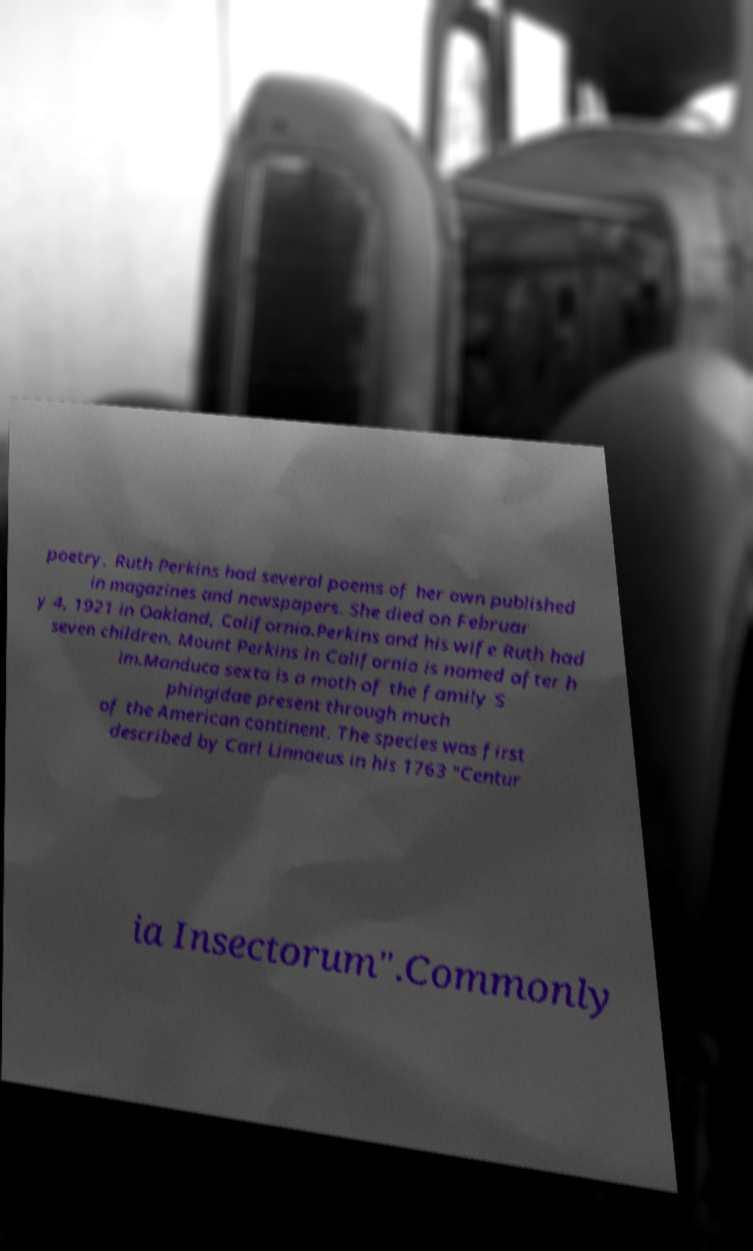For documentation purposes, I need the text within this image transcribed. Could you provide that? poetry, Ruth Perkins had several poems of her own published in magazines and newspapers. She died on Februar y 4, 1921 in Oakland, California.Perkins and his wife Ruth had seven children. Mount Perkins in California is named after h im.Manduca sexta is a moth of the family S phingidae present through much of the American continent. The species was first described by Carl Linnaeus in his 1763 "Centur ia Insectorum".Commonly 